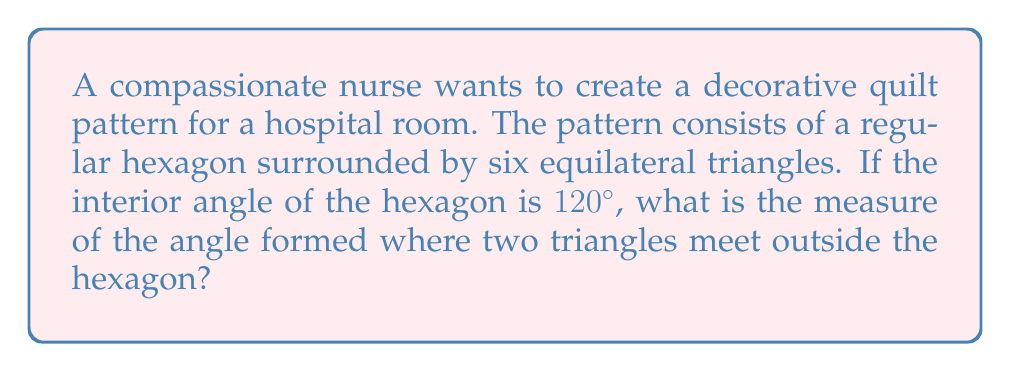Can you solve this math problem? Let's approach this step-by-step:

1) First, recall that the sum of angles in a triangle is 180°.

2) In an equilateral triangle, all angles are equal. So, each angle in the equilateral triangles is:
   $$ \frac{180°}{3} = 60° $$

3) At the point where two triangles meet outside the hexagon, we have:
   - One angle from each of the two triangles
   - The exterior angle of the hexagon

4) The exterior angle of a regular hexagon is supplementary to its interior angle:
   $$ 180° - 120° = 60° $$

5) So, at the point where two triangles meet, we have:
   - 60° from one triangle
   - 60° from the other triangle
   - 60° from the exterior angle of the hexagon

6) The sum of these angles must be 360° for a complete rotation:
   $$ 60° + 60° + x = 360° $$
   where $x$ is the angle we're looking for.

7) Solving for $x$:
   $$ x = 360° - (60° + 60°) = 360° - 120° = 240° $$

Therefore, the angle formed where two triangles meet outside the hexagon is 240°.

[asy]
unitsize(1cm);

pair A=(0,0), B=(2,0), C=(3,sqrt(3)), D=(2,2*sqrt(3)), E=(0,2*sqrt(3)), F=(-1,sqrt(3));
pair G=(4,0), H=(5,sqrt(3)), I=(1,2*sqrt(3)+1), J=(-2,2*sqrt(3)), K=(-3,sqrt(3)), L=(-1,-sqrt(3));

draw(A--B--C--D--E--F--cycle);
draw(B--G--H--C);
draw(D--I--E);
draw(F--K--J--E);
draw(A--L--F);

label("240°", (B+G+H)/3, E);

</asy]
Answer: 240° 